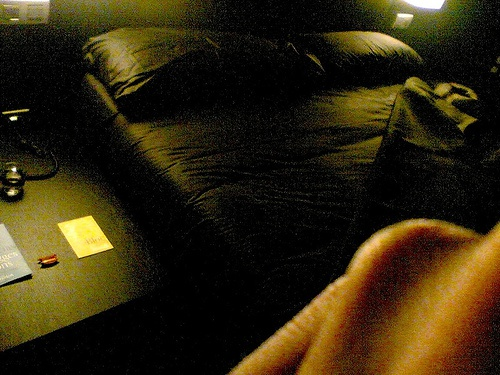Describe the objects in this image and their specific colors. I can see a bed in tan, black, and olive tones in this image. 